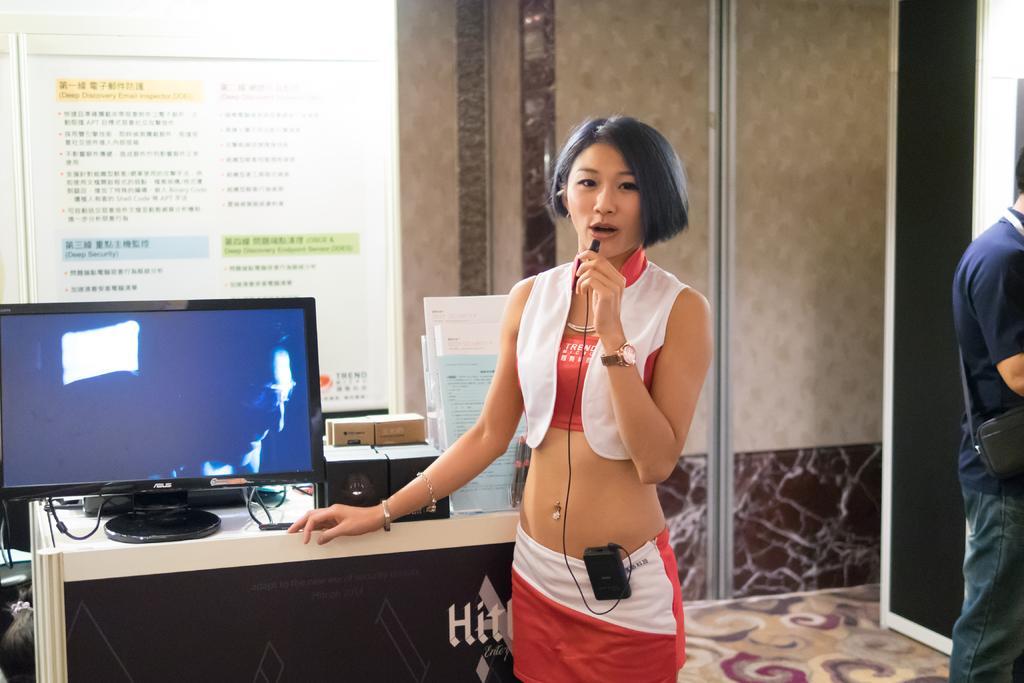Could you give a brief overview of what you see in this image? In the given image we can see that a women who is standing and holding microphone in her hand. She is wearing a wrist watch. There is a system beside her. Beside her there is a another man standing. 